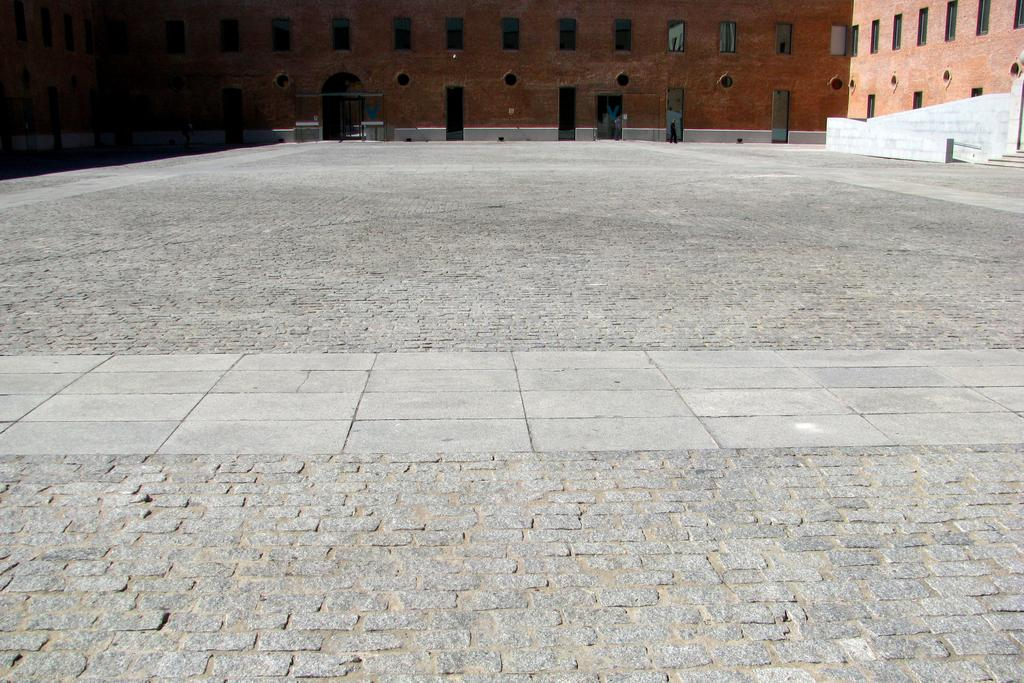What type of terrain can be seen in the image? There is land visible in the image. What structure is present on the land? There is a building in the image. What feature can be observed on the building? The building has glass windows. Where is the building located in the image? The building is located at the top of the image. What type of gold ornaments are hanging from the windows of the building in the image? There is no mention of gold ornaments in the image; the building has glass windows. Can you see a guitar being played on the land in the image? There is no guitar or any musical activity depicted in the image. 